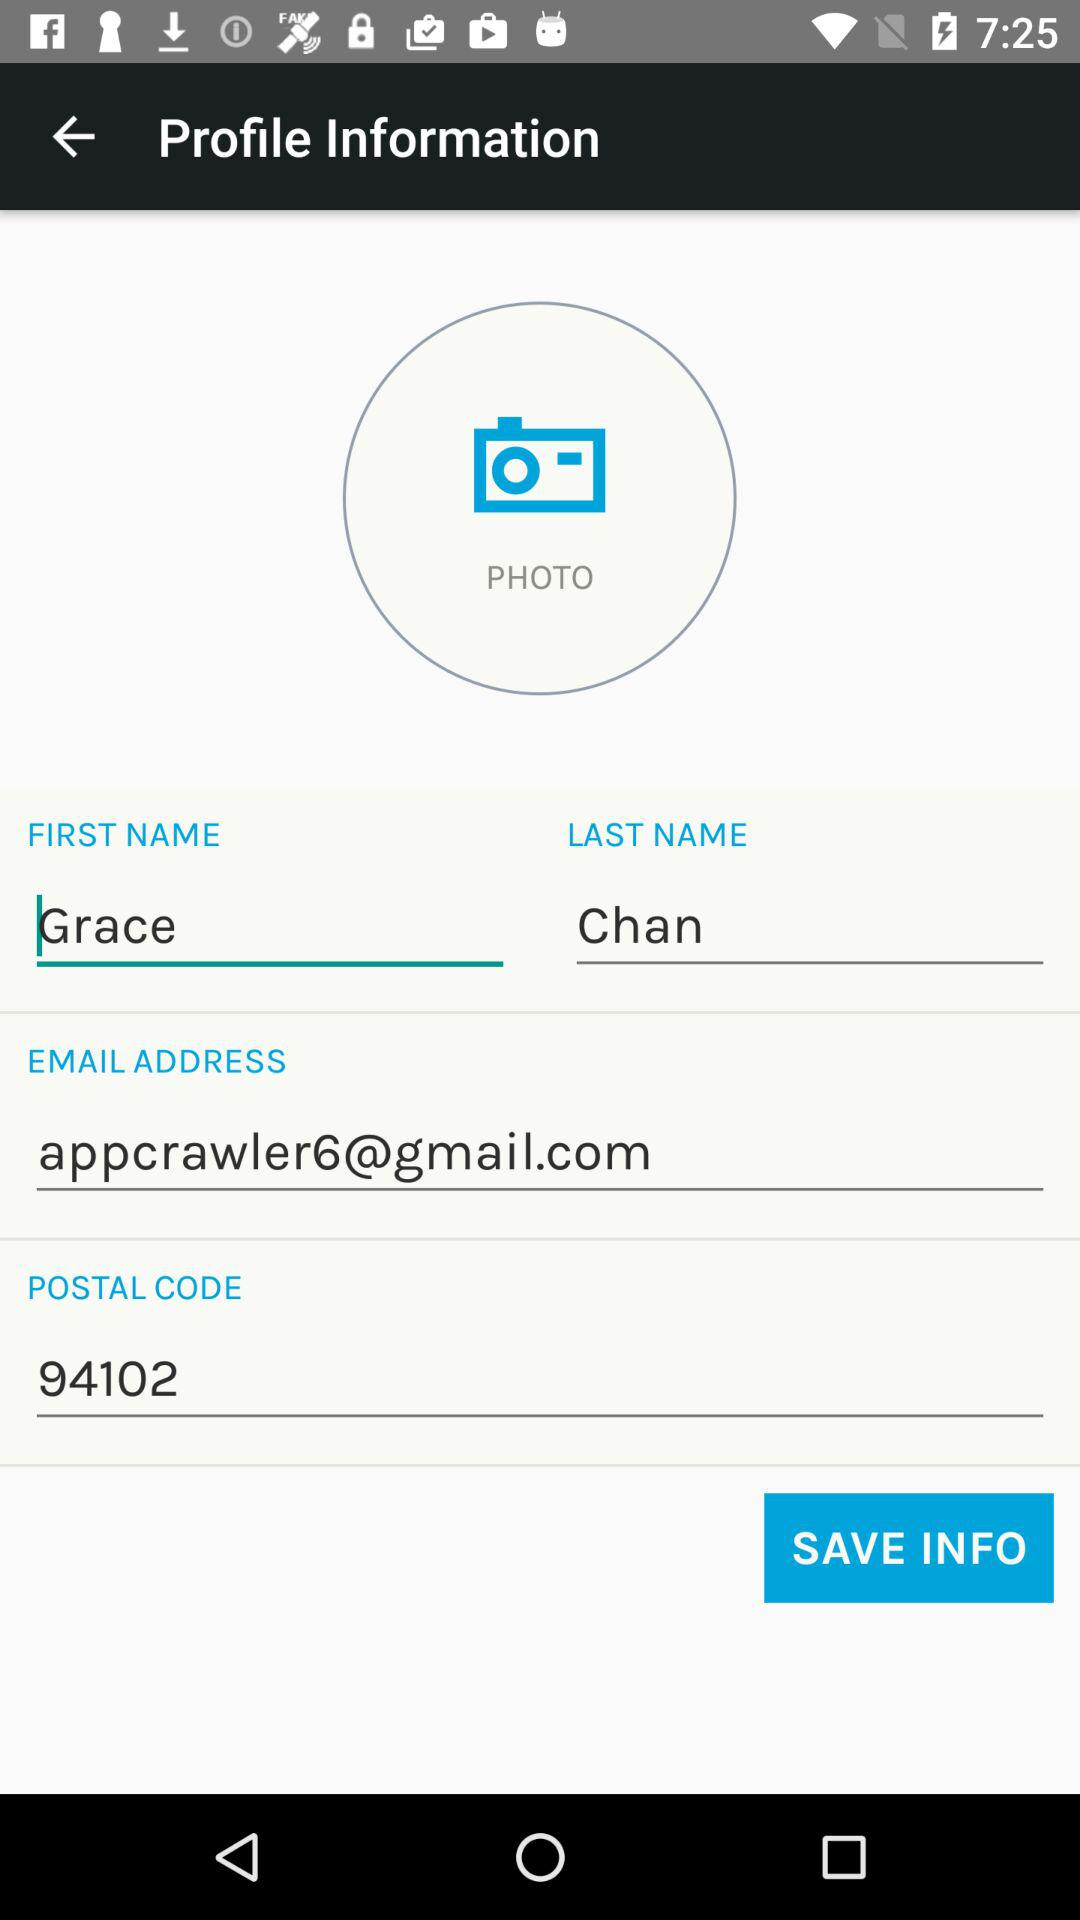What is the first name? The first name is Grace. 